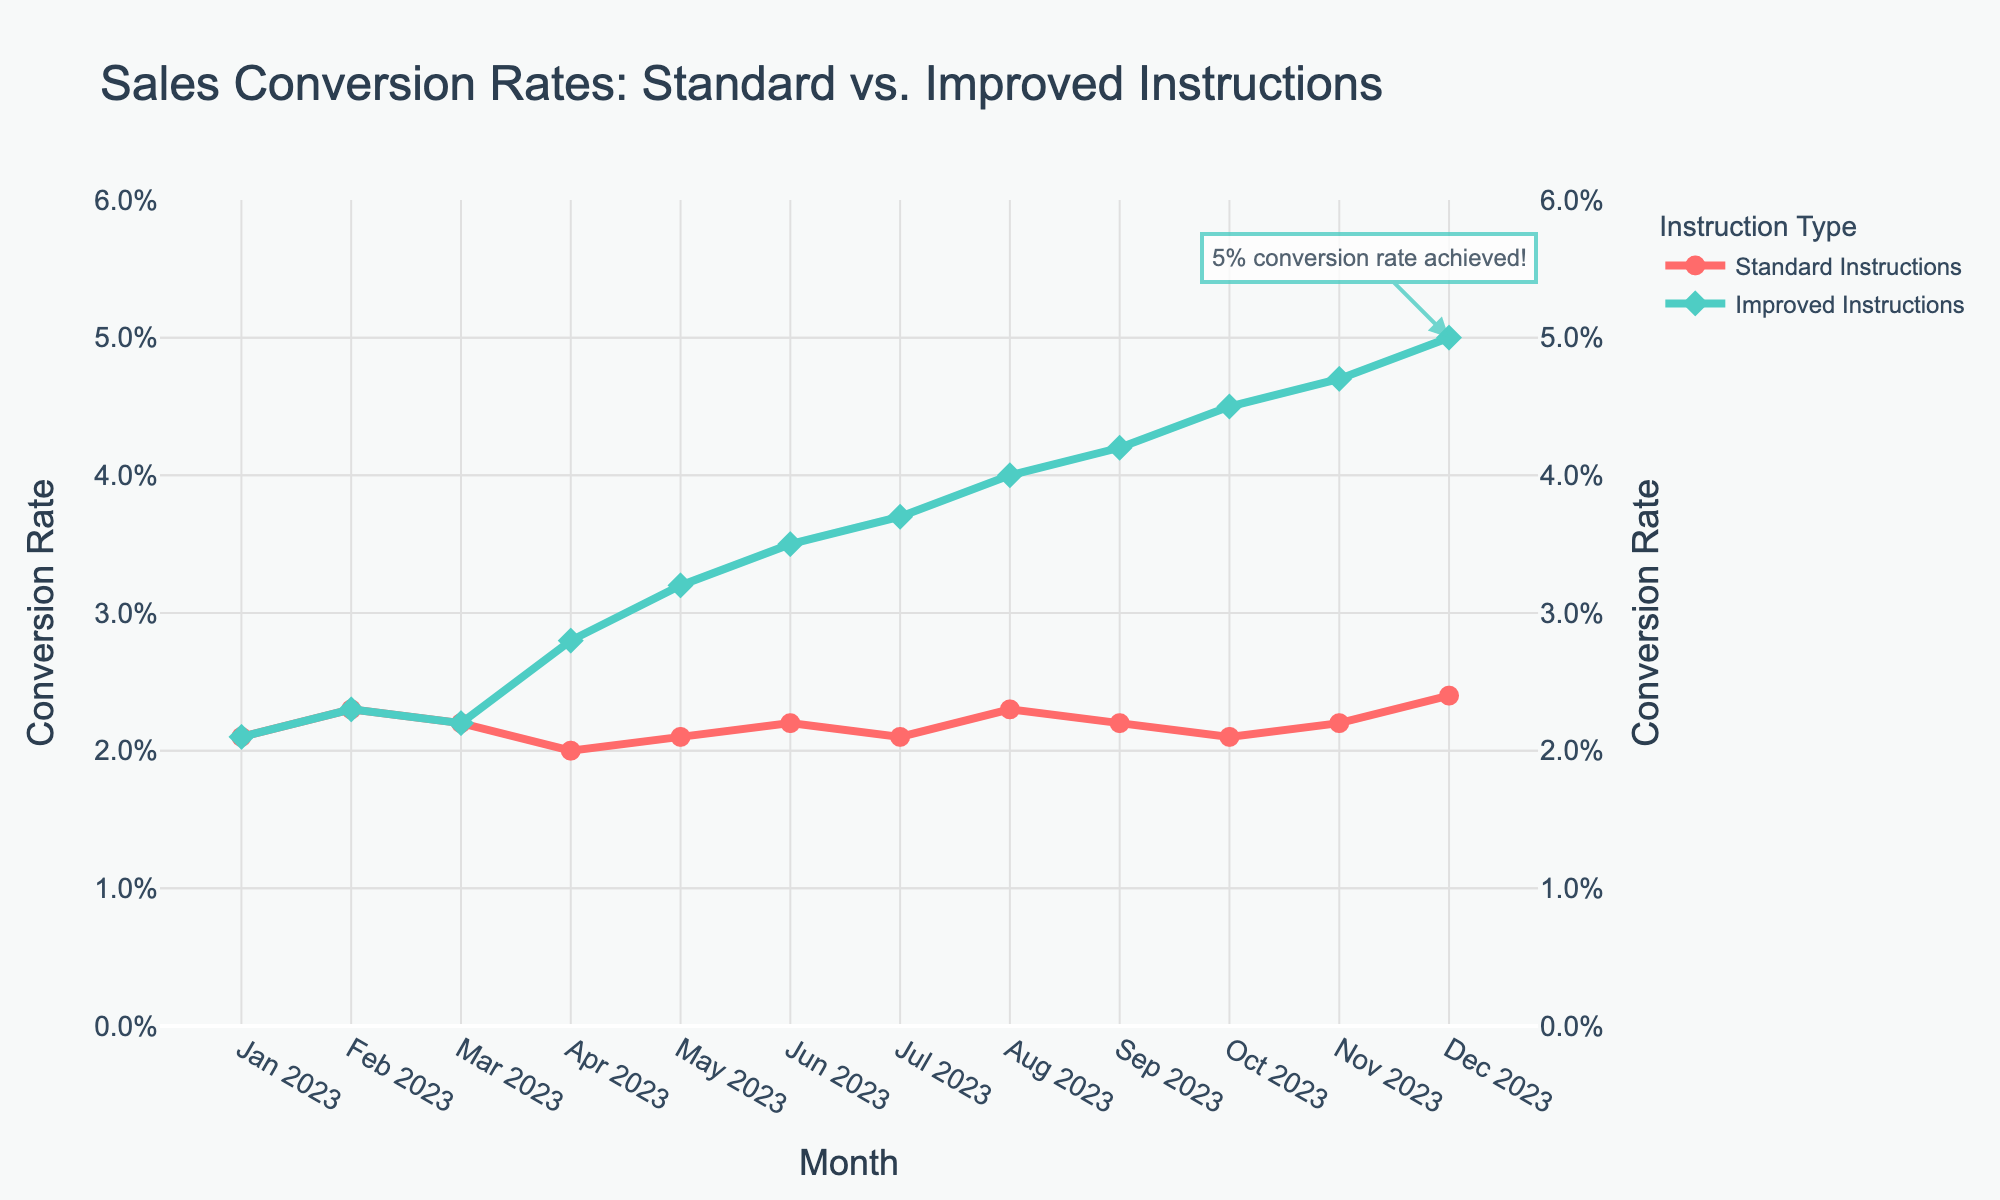What trend do you observe in the sales conversion rate for Improved Instructions from April 2023 to December 2023? The sales conversion rate for Improved Instructions shows a consistent upward trend from April 2023 to December 2023. It starts from 2.8% in April 2023 and increases steadily to 5.0% in December 2023. This trend indicates that the implementation of Improved Instructions is positively affecting the conversion rates over time.
Answer: Upward trend How does the sales conversion rate in December 2023 compare between Standard Instructions and Improved Instructions? In December 2023, the conversion rate for Improved Instructions is 5.0%, whereas for Standard Instructions, it is 2.4%. By comparing these values, we see that Improved Instructions have a significantly higher conversion rate in December 2023, indicating better performance.
Answer: Improved Instructions: 5.0%, Standard Instructions: 2.4% Between which two months does the sales conversion rate of Improved Instructions see the highest increase? The highest increase in conversion rate for Improved Instructions occurs between April 2023 (2.8%) and May 2023 (3.2%). The increase is 0.4%. By looking at the monthly differences, this period shows the most significant rise.
Answer: April 2023 to May 2023 What is the difference between the conversion rates of Standard Instructions and Improved Instructions in November 2023? In November 2023, the conversion rate for Standard Instructions is 2.2%, while for Improved Instructions, it is 4.7%. The difference between them is 4.7% - 2.2% = 2.5%.
Answer: 2.5% On which month do Improved Instructions exceed a 4% conversion rate? The Improved Instructions exceed a 4% conversion rate in August 2023, where the conversion rate is exactly 4.0%. This is the first month where the conversion rate surpasses 4%.
Answer: August 2023 What is the average conversion rate for Standard Instructions over the entire year of 2023? To find the average, sum all the conversion rates for Standard Instructions and then divide by the number of months. The sum of conversion rates for Standard Instructions from January to December 2023 is: (2.1% + 2.3% + 2.2% + 2.0% + 2.1% + 2.2% + 2.1% + 2.3% + 2.2% + 2.1% + 2.2% + 2.4%) = 26.2%. Then, divide by 12 months to get the average conversion rate: 26.2% / 12 = 2.183%, which can be approximated to 2.18%.
Answer: 2.18% Does the conversion rate for Standard Instructions ever change between January and December 2023? Yes, the conversion rate for Standard Instructions fluctuates slightly within the range of 2.0% to 2.4% across different months in 2023. These small changes indicate variability in the conversion rates but without any significant trend.
Answer: Yes What color represents the Improved Instructions line in the chart, and what does this color symbolize in the context of the plot? The Improved Instructions line is represented by green in the chart. In the context of the plot, green typically symbolizes growth and improvement, which aligns with the increasing conversion rates shown for Improved Instructions.
Answer: Green 